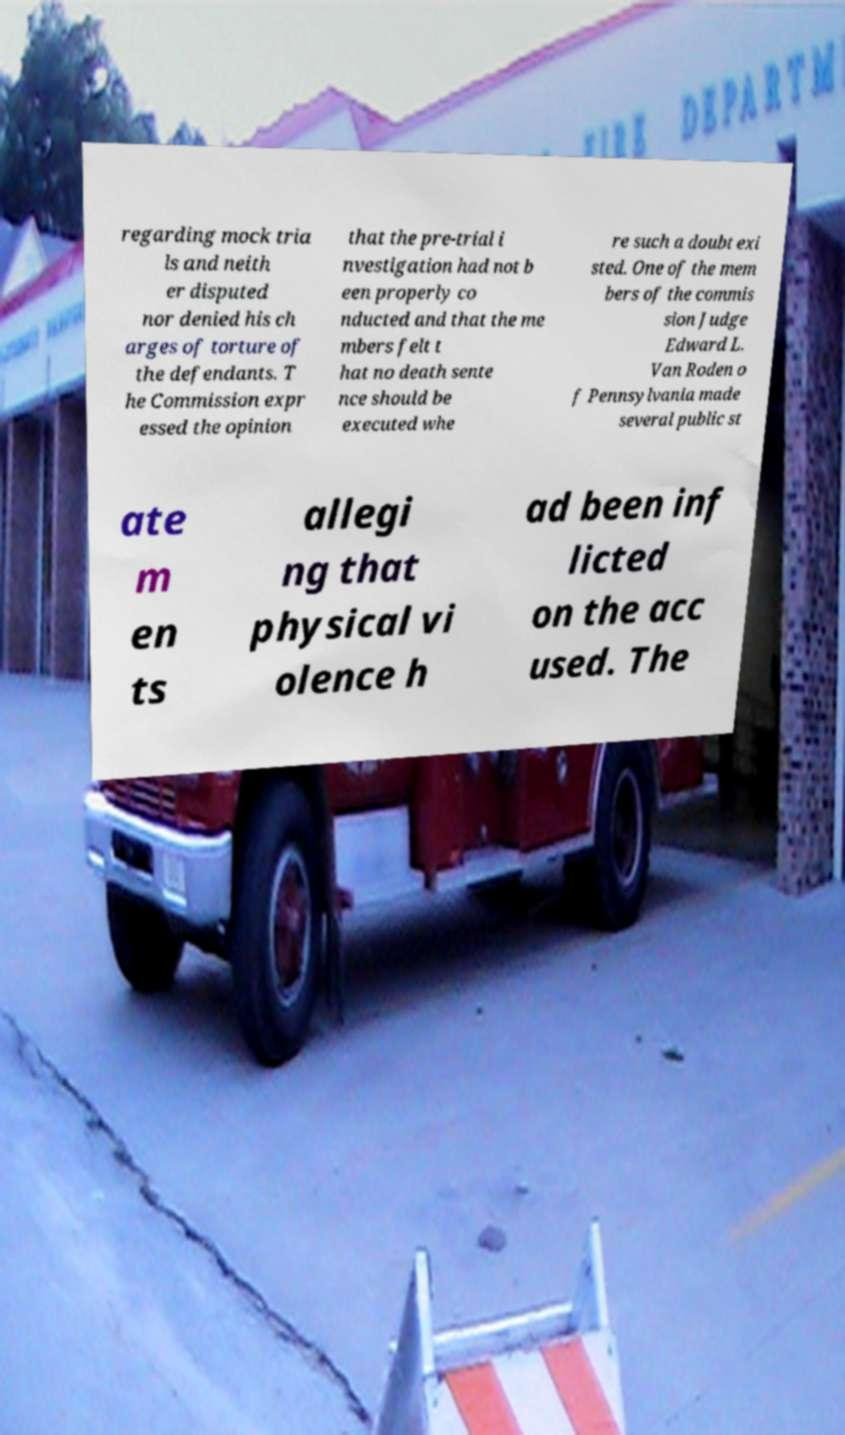Could you extract and type out the text from this image? regarding mock tria ls and neith er disputed nor denied his ch arges of torture of the defendants. T he Commission expr essed the opinion that the pre-trial i nvestigation had not b een properly co nducted and that the me mbers felt t hat no death sente nce should be executed whe re such a doubt exi sted. One of the mem bers of the commis sion Judge Edward L. Van Roden o f Pennsylvania made several public st ate m en ts allegi ng that physical vi olence h ad been inf licted on the acc used. The 